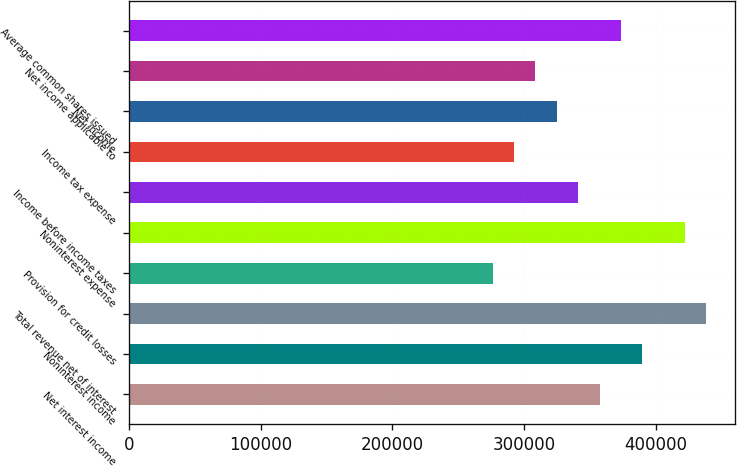Convert chart. <chart><loc_0><loc_0><loc_500><loc_500><bar_chart><fcel>Net interest income<fcel>Noninterest income<fcel>Total revenue net of interest<fcel>Provision for credit losses<fcel>Noninterest expense<fcel>Income before income taxes<fcel>Income tax expense<fcel>Net income<fcel>Net income applicable to<fcel>Average common shares issued<nl><fcel>357405<fcel>389897<fcel>438634<fcel>276177<fcel>422388<fcel>341160<fcel>292423<fcel>324914<fcel>308668<fcel>373651<nl></chart> 